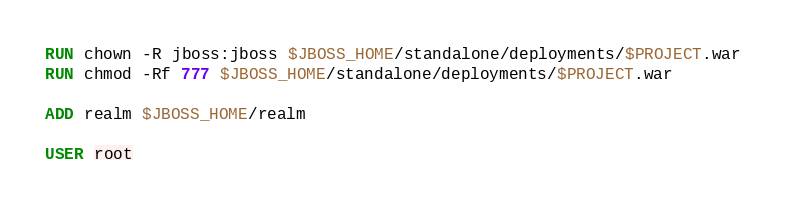<code> <loc_0><loc_0><loc_500><loc_500><_Dockerfile_>RUN chown -R jboss:jboss $JBOSS_HOME/standalone/deployments/$PROJECT.war
RUN chmod -Rf 777 $JBOSS_HOME/standalone/deployments/$PROJECT.war

ADD realm $JBOSS_HOME/realm

USER root

</code> 